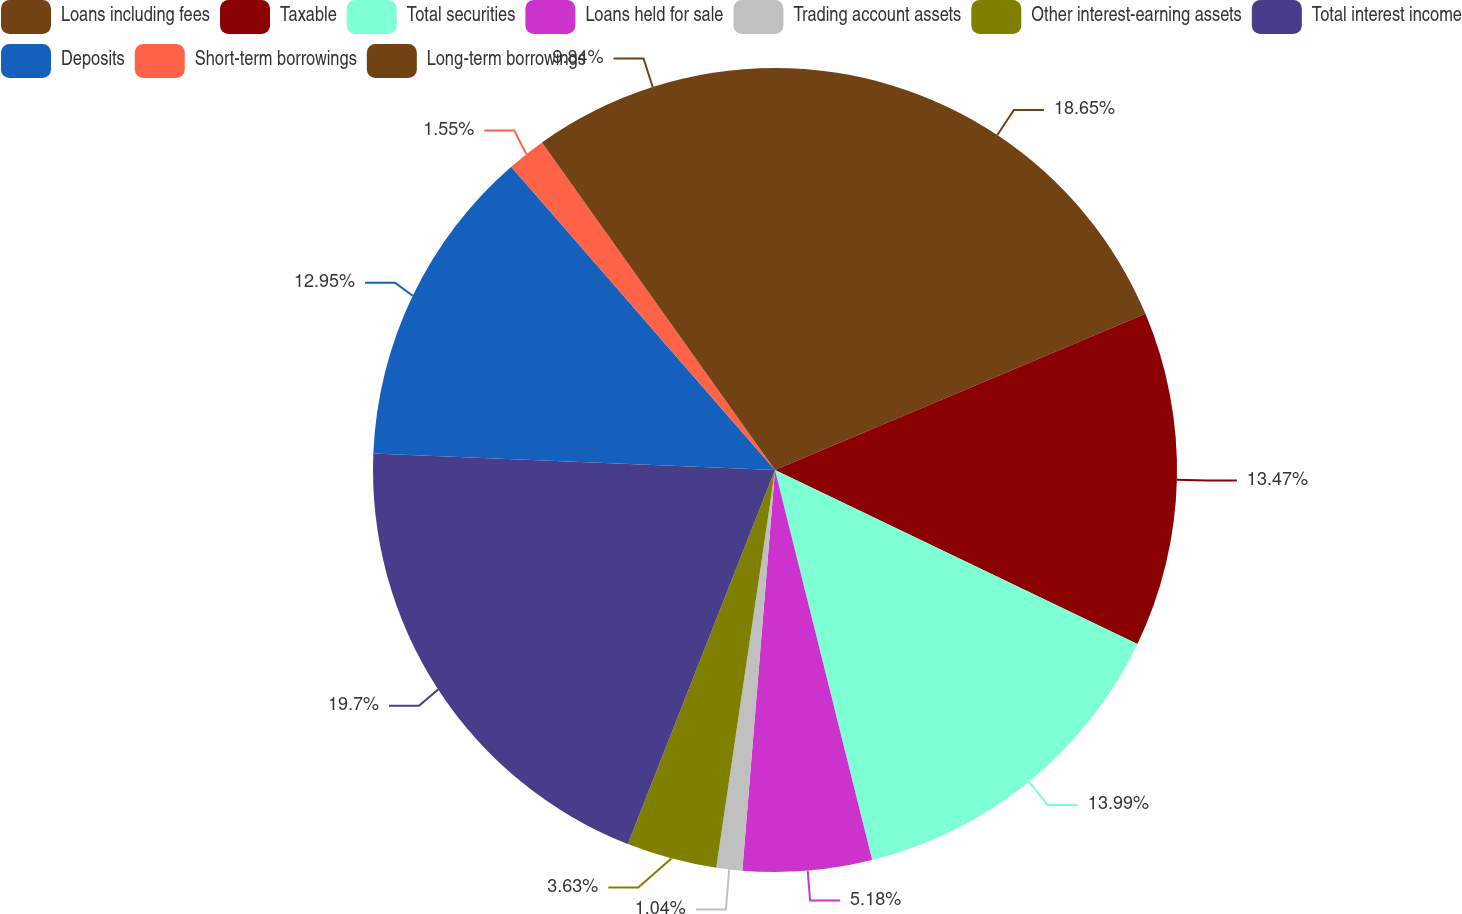<chart> <loc_0><loc_0><loc_500><loc_500><pie_chart><fcel>Loans including fees<fcel>Taxable<fcel>Total securities<fcel>Loans held for sale<fcel>Trading account assets<fcel>Other interest-earning assets<fcel>Total interest income<fcel>Deposits<fcel>Short-term borrowings<fcel>Long-term borrowings<nl><fcel>18.65%<fcel>13.47%<fcel>13.99%<fcel>5.18%<fcel>1.04%<fcel>3.63%<fcel>19.69%<fcel>12.95%<fcel>1.55%<fcel>9.84%<nl></chart> 